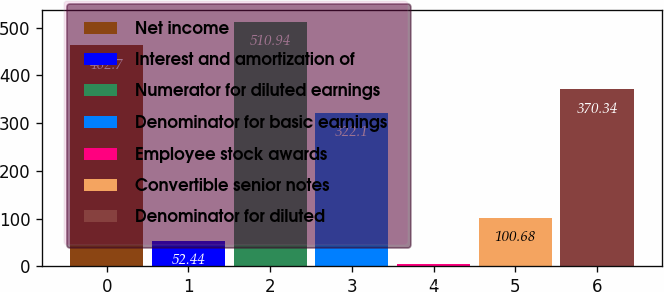Convert chart to OTSL. <chart><loc_0><loc_0><loc_500><loc_500><bar_chart><fcel>Net income<fcel>Interest and amortization of<fcel>Numerator for diluted earnings<fcel>Denominator for basic earnings<fcel>Employee stock awards<fcel>Convertible senior notes<fcel>Denominator for diluted<nl><fcel>462.7<fcel>52.44<fcel>510.94<fcel>322.1<fcel>4.2<fcel>100.68<fcel>370.34<nl></chart> 